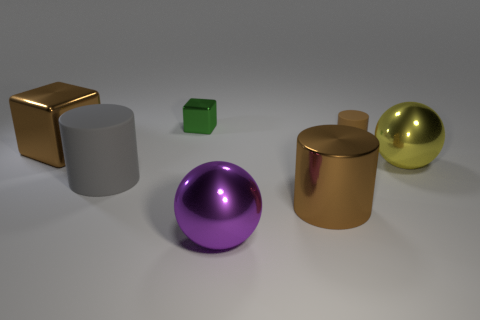Is there a big gray cylinder that has the same material as the tiny cylinder?
Your answer should be compact. Yes. There is a cylinder that is the same color as the tiny matte object; what is its size?
Keep it short and to the point. Large. What color is the large shiny sphere behind the big gray rubber cylinder?
Ensure brevity in your answer.  Yellow. There is a gray object; does it have the same shape as the brown thing that is on the left side of the large purple thing?
Offer a very short reply. No. Are there any large things of the same color as the large shiny cylinder?
Your response must be concise. Yes. The cylinder that is made of the same material as the large gray object is what size?
Your response must be concise. Small. Does the large metal cylinder have the same color as the tiny rubber object?
Give a very brief answer. Yes. Does the shiny thing behind the tiny brown cylinder have the same shape as the big gray rubber object?
Make the answer very short. No. What number of objects are the same size as the brown cube?
Provide a short and direct response. 4. The large metallic object that is the same color as the shiny cylinder is what shape?
Make the answer very short. Cube. 